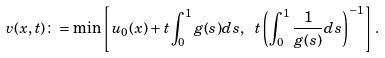<formula> <loc_0><loc_0><loc_500><loc_500>v ( x , t ) \colon = \min \left [ u _ { 0 } ( x ) + t \int _ { 0 } ^ { 1 } g ( s ) d s , \ t \left ( \int _ { 0 } ^ { 1 } \frac { 1 } { g ( s ) } d s \right ) ^ { - 1 } \right ] .</formula> 